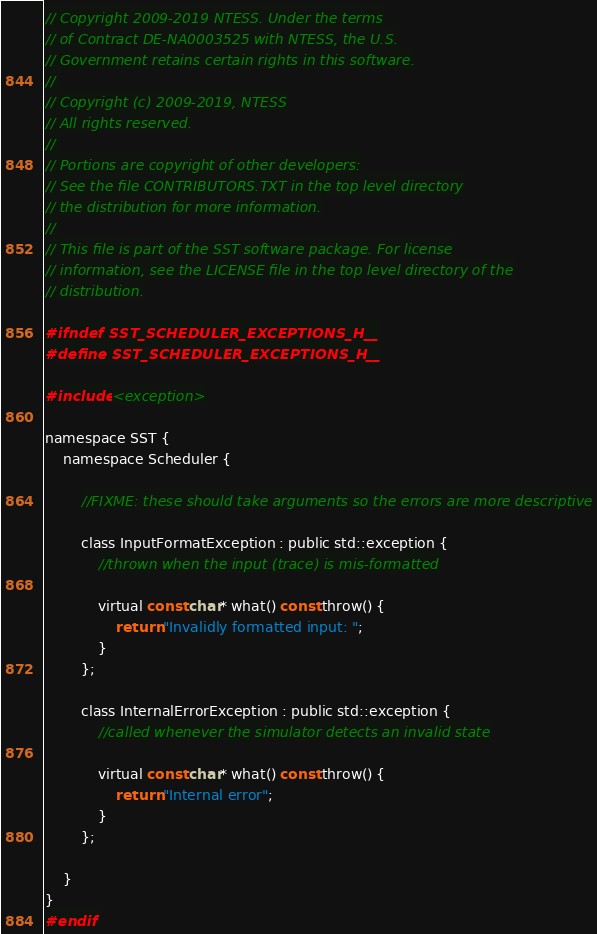<code> <loc_0><loc_0><loc_500><loc_500><_C_>// Copyright 2009-2019 NTESS. Under the terms
// of Contract DE-NA0003525 with NTESS, the U.S.
// Government retains certain rights in this software.
// 
// Copyright (c) 2009-2019, NTESS
// All rights reserved.
// 
// Portions are copyright of other developers:
// See the file CONTRIBUTORS.TXT in the top level directory
// the distribution for more information.
//
// This file is part of the SST software package. For license
// information, see the LICENSE file in the top level directory of the
// distribution.

#ifndef SST_SCHEDULER_EXCEPTIONS_H__
#define SST_SCHEDULER_EXCEPTIONS_H__

#include <exception>

namespace SST {
    namespace Scheduler {

        //FIXME: these should take arguments so the errors are more descriptive

        class InputFormatException : public std::exception {
            //thrown when the input (trace) is mis-formatted

            virtual const char* what() const throw() {
                return "Invalidly formatted input: ";
            }
        };

        class InternalErrorException : public std::exception {
            //called whenever the simulator detects an invalid state

            virtual const char* what() const throw() {
                return "Internal error";
            }
        };

    }
}
#endif
</code> 